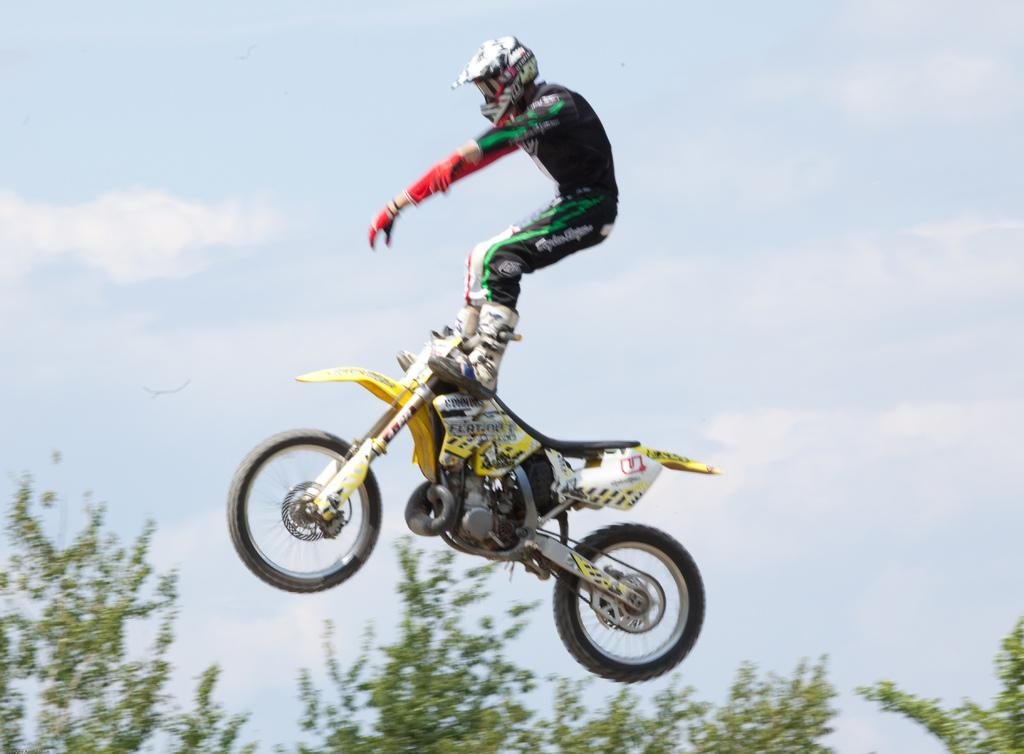What is the main subject of the image? There is a man in the image. What is the man doing in the image? The man is riding a bike. What safety gear is the man wearing in the image? The man is wearing a helmet in the image. What type of vegetation can be seen at the bottom of the image? There are trees at the bottom of the image. What is visible in the sky at the top of the image? There are clouds in the sky at the top of the image. Can you tell me who created the bell that the man is ringing in the image? There is no bell present in the image, and therefore no creator to mention. Is the man riding his bike in the snow in the image? There is no snow visible in the image, and the man is not riding his bike in any specific weather condition. 